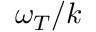Convert formula to latex. <formula><loc_0><loc_0><loc_500><loc_500>\omega _ { T } / k</formula> 